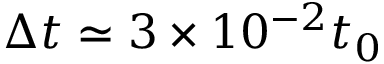<formula> <loc_0><loc_0><loc_500><loc_500>\Delta t \simeq 3 \times 1 0 ^ { - 2 } t _ { 0 }</formula> 